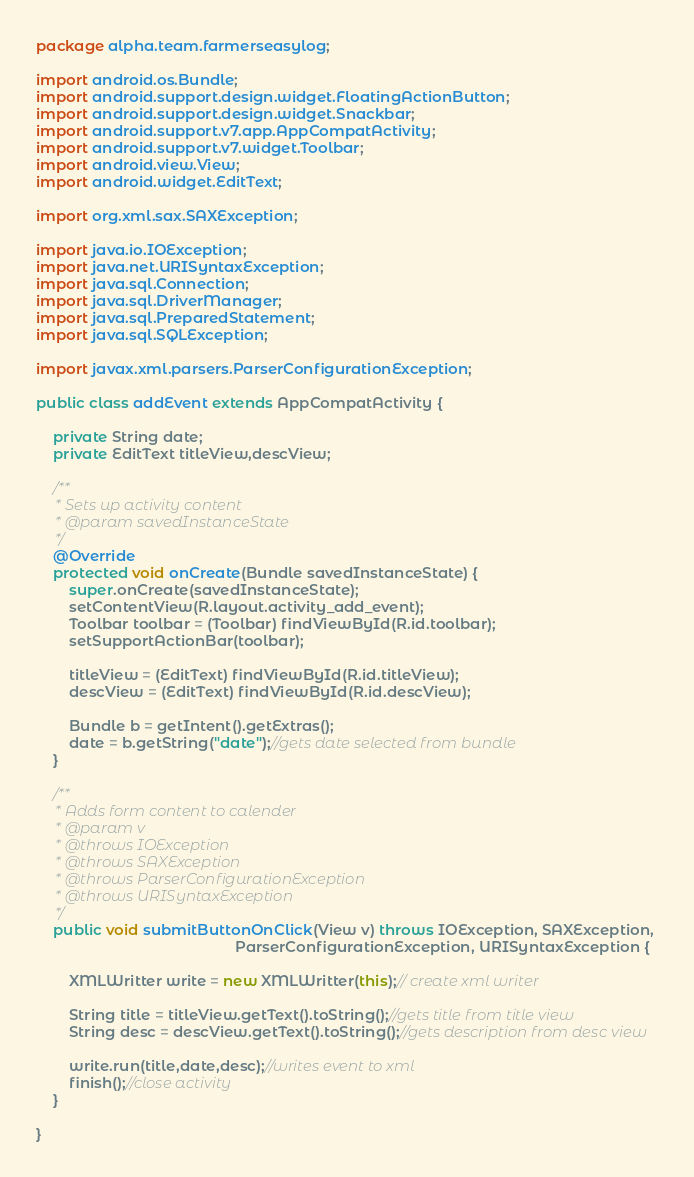<code> <loc_0><loc_0><loc_500><loc_500><_Java_>package alpha.team.farmerseasylog;

import android.os.Bundle;
import android.support.design.widget.FloatingActionButton;
import android.support.design.widget.Snackbar;
import android.support.v7.app.AppCompatActivity;
import android.support.v7.widget.Toolbar;
import android.view.View;
import android.widget.EditText;

import org.xml.sax.SAXException;

import java.io.IOException;
import java.net.URISyntaxException;
import java.sql.Connection;
import java.sql.DriverManager;
import java.sql.PreparedStatement;
import java.sql.SQLException;

import javax.xml.parsers.ParserConfigurationException;

public class addEvent extends AppCompatActivity {

    private String date;
    private EditText titleView,descView;

    /**
     * Sets up activity content
     * @param savedInstanceState
     */
    @Override
    protected void onCreate(Bundle savedInstanceState) {
        super.onCreate(savedInstanceState);
        setContentView(R.layout.activity_add_event);
        Toolbar toolbar = (Toolbar) findViewById(R.id.toolbar);
        setSupportActionBar(toolbar);

        titleView = (EditText) findViewById(R.id.titleView);
        descView = (EditText) findViewById(R.id.descView);

        Bundle b = getIntent().getExtras();
        date = b.getString("date");//gets date selected from bundle
    }

    /**
     * Adds form content to calender
     * @param v
     * @throws IOException
     * @throws SAXException
     * @throws ParserConfigurationException
     * @throws URISyntaxException
     */
    public void submitButtonOnClick(View v) throws IOException, SAXException,
                                                ParserConfigurationException, URISyntaxException {

        XMLWritter write = new XMLWritter(this);// create xml writer

        String title = titleView.getText().toString();//gets title from title view
        String desc = descView.getText().toString();//gets description from desc view

        write.run(title,date,desc);//writes event to xml
        finish();//close activity
    }

}
</code> 